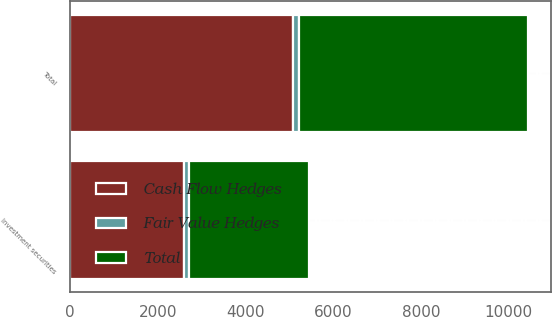Convert chart. <chart><loc_0><loc_0><loc_500><loc_500><stacked_bar_chart><ecel><fcel>Investment securities<fcel>Total<nl><fcel>Cash Flow Hedges<fcel>2589<fcel>5089<nl><fcel>Fair Value Hedges<fcel>132<fcel>132<nl><fcel>Total<fcel>2721<fcel>5221<nl></chart> 